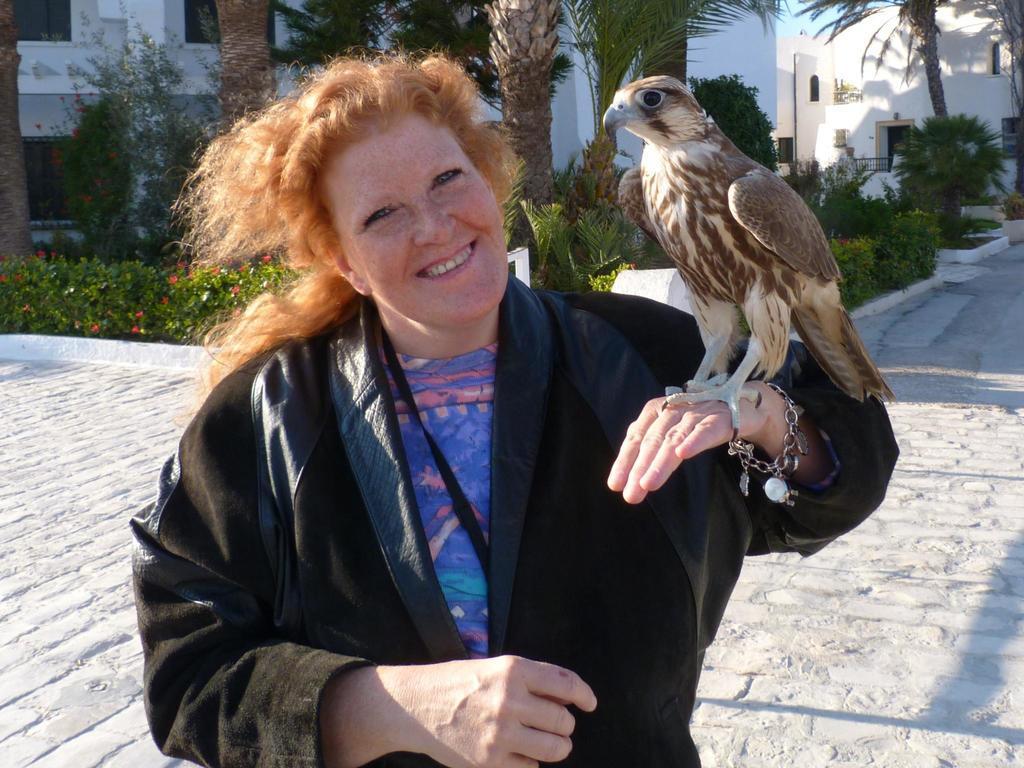Can you describe this image briefly? In this picture I can see a woman and a eagle on her hand and I can see trees and buildings in the back and I can see plants in the middle. 